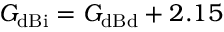Convert formula to latex. <formula><loc_0><loc_0><loc_500><loc_500>G _ { d B i } = G _ { d B d } + 2 . 1 5</formula> 